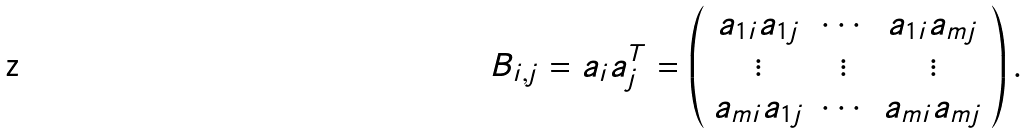Convert formula to latex. <formula><loc_0><loc_0><loc_500><loc_500>B _ { i , j } = a _ { i } a _ { j } ^ { T } = \left ( \begin{array} { c c c } a _ { 1 i } a _ { 1 j } & \cdots & a _ { 1 i } a _ { m j } \\ \vdots & \vdots & \vdots \\ a _ { m i } a _ { 1 j } & \cdots & a _ { m i } a _ { m j } \end{array} \right ) .</formula> 